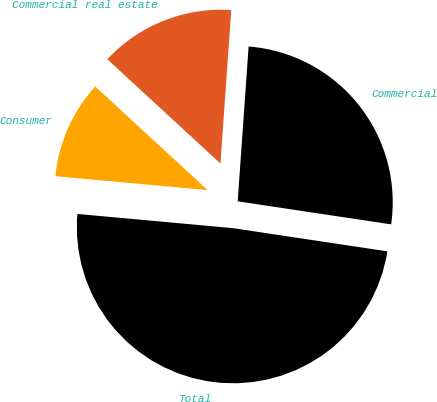<chart> <loc_0><loc_0><loc_500><loc_500><pie_chart><fcel>Commercial<fcel>Commercial real estate<fcel>Consumer<fcel>Total<nl><fcel>26.25%<fcel>14.27%<fcel>10.4%<fcel>49.07%<nl></chart> 